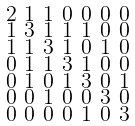Convert formula to latex. <formula><loc_0><loc_0><loc_500><loc_500>\begin{smallmatrix} 2 & 1 & 1 & 0 & 0 & 0 & 0 \\ 1 & 3 & 1 & 1 & 1 & 0 & 0 \\ 1 & 1 & 3 & 1 & 0 & 1 & 0 \\ 0 & 1 & 1 & 3 & 1 & 0 & 0 \\ 0 & 1 & 0 & 1 & 3 & 0 & 1 \\ 0 & 0 & 1 & 0 & 0 & 3 & 0 \\ 0 & 0 & 0 & 0 & 1 & 0 & 3 \end{smallmatrix}</formula> 